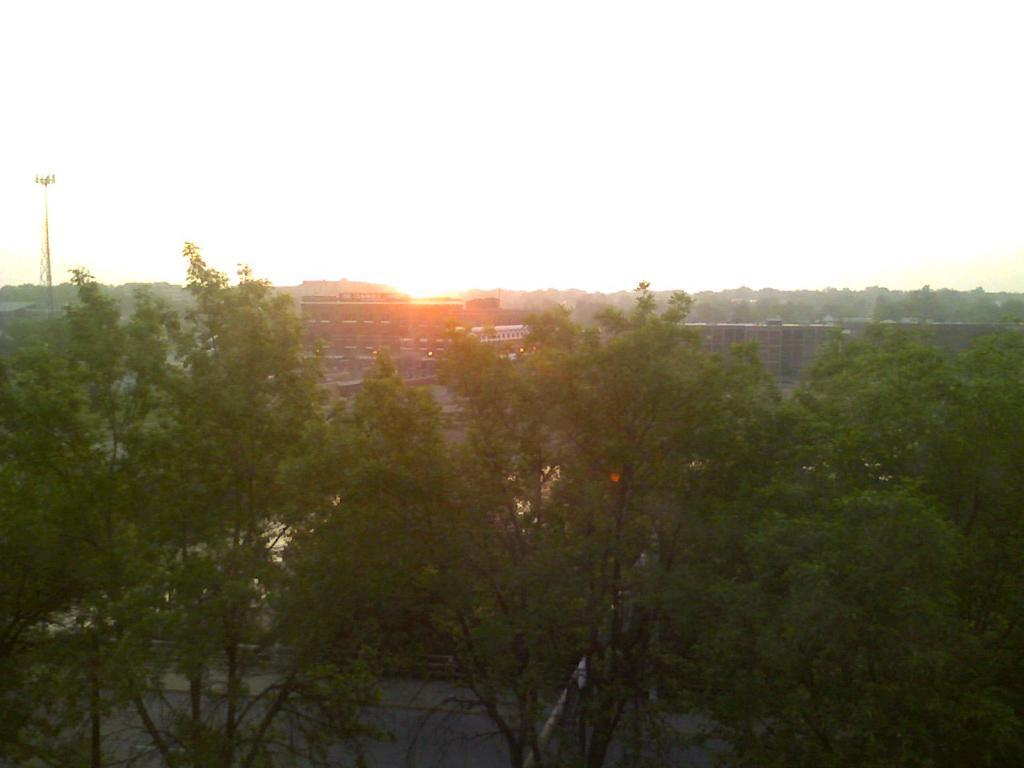How would you summarize this image in a sentence or two? In this image I can see few trees in green color. In the background I can see few buildings and the tower and the sky is in white color. 